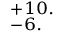<formula> <loc_0><loc_0><loc_500><loc_500>^ { + 1 0 . } _ { - 6 . }</formula> 